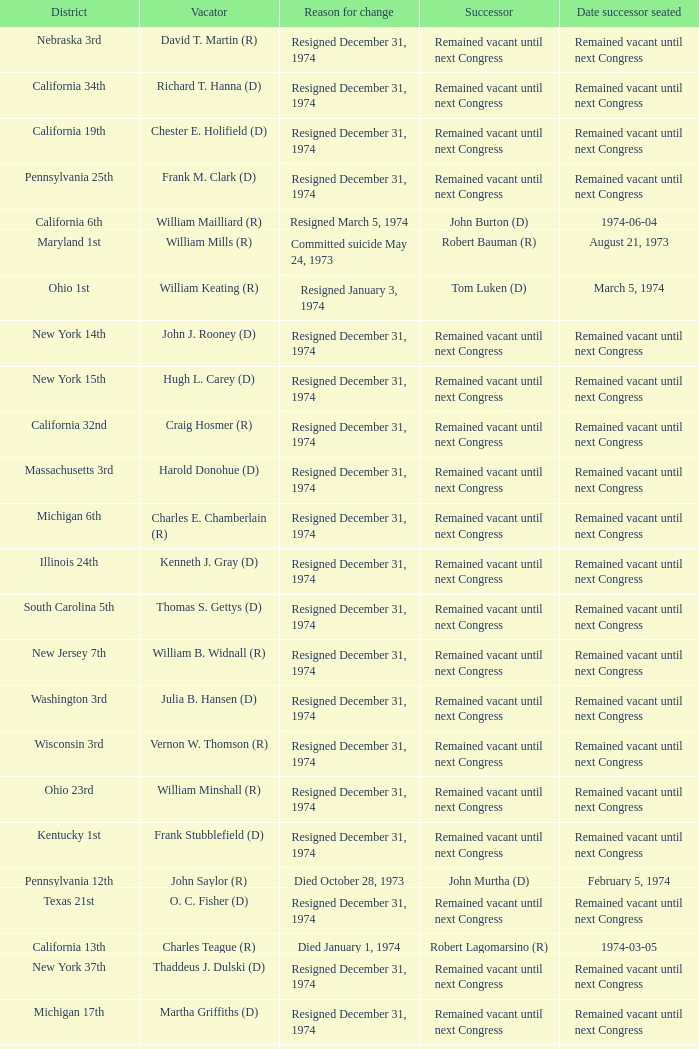What was the district when the reason for change was died January 1, 1974? California 13th. 